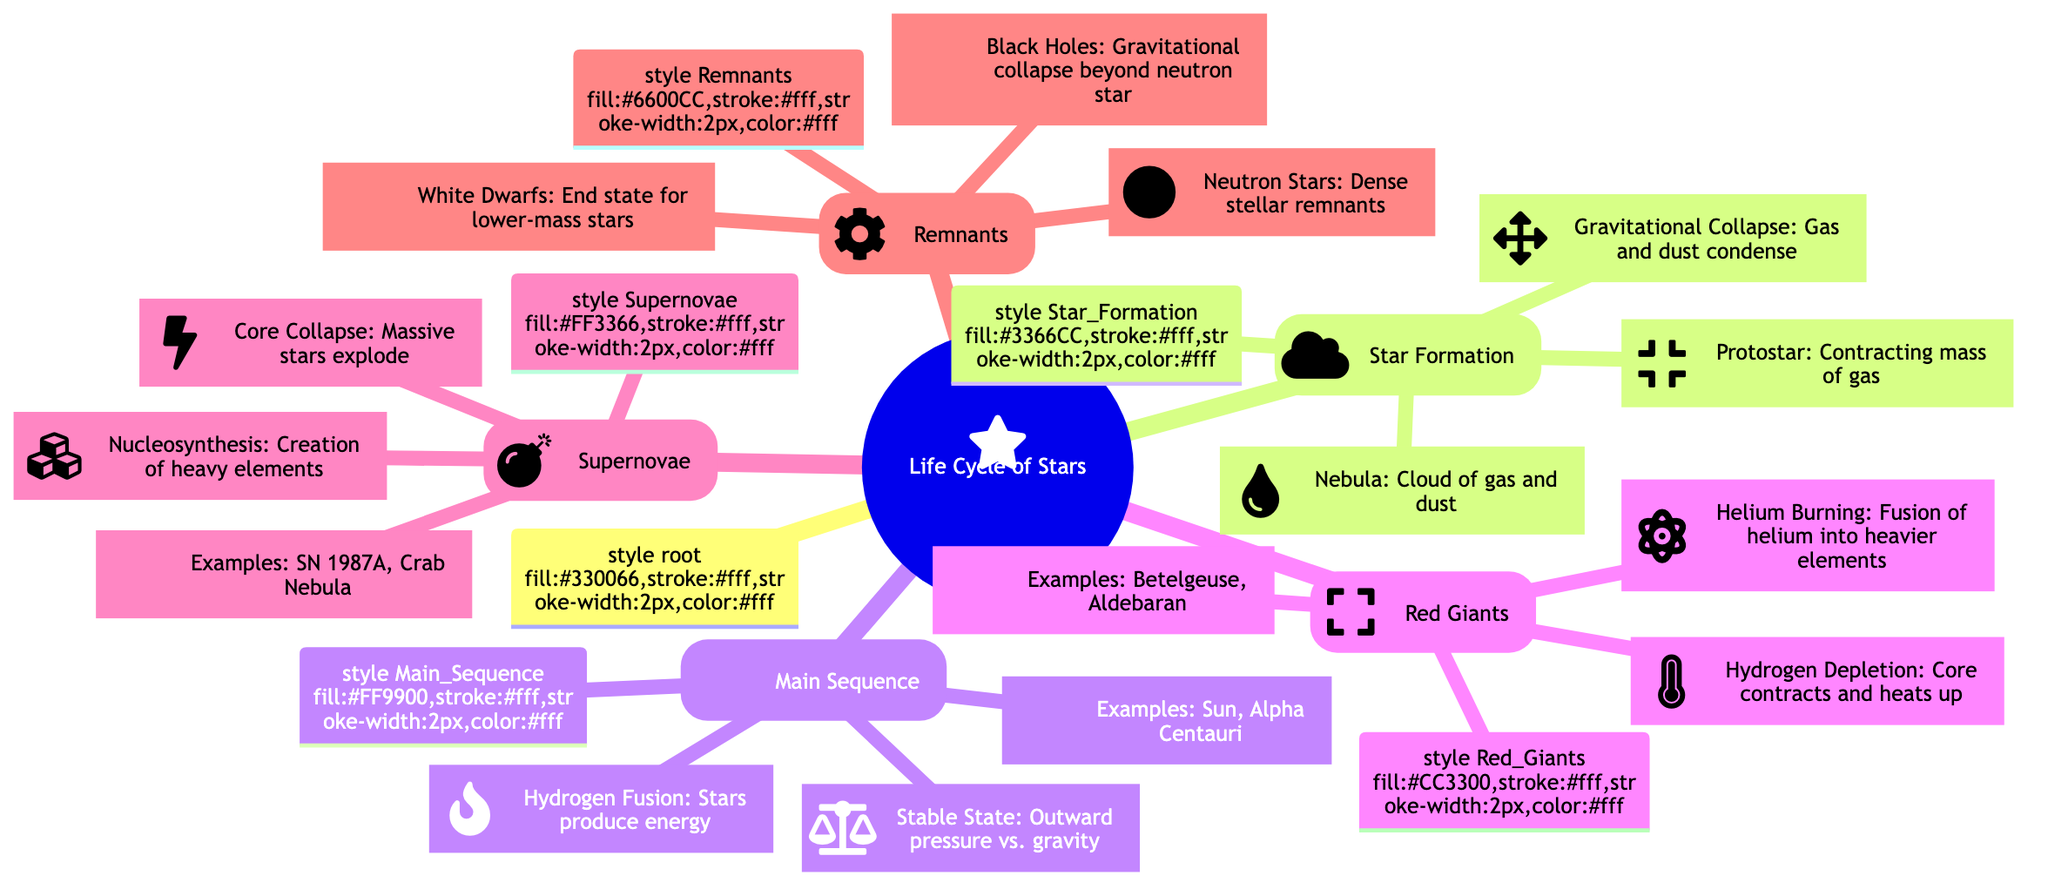What are the three stages of star formation? According to the diagram, the three stages of star formation listed are "Nebula," "Protostar," and "Gravitational Collapse." These are the initial phases that a star goes through before entering the main sequence.
Answer: Nebula, Protostar, Gravitational Collapse How many examples of red giants are mentioned? The diagram states that there are two examples of red giants, specifically "Betelgeuse" and "Aldebaran." Therefore, we count these to determine the total.
Answer: Two What key process occurs during the main sequence stage? The diagram highlights "Hydrogen Fusion" as a significant process during the main sequence of a star's life cycle, which is critical for energy production.
Answer: Hydrogen Fusion What happens during a supernova? According to the diagram, during a supernova, there is a "Core Collapse" where massive stars explode. This dramatic event is part of the life cycle of stars.
Answer: Core Collapse What are the remnants of a star after a supernova? The diagram lists three types of stellar remnants after a supernova: "Neutron Stars," "Black Holes," and "White Dwarfs." These represent the end states that stars may collapse into.
Answer: Neutron Stars, Black Holes, White Dwarfs What is the relationship between hydrogen depletion and red giants? The diagram indicates that "Hydrogen Depletion" leads to "Helium Burning," which is a condition that occurs in red giants as they exhaust their hydrogen supply and start fusing helium.
Answer: Hydrogen Depletion leads to Helium Burning What type of celestial object is formed from core collapse? The diagram illustrates that from core collapse, one possible outcome is a "Neutron Star," which reflects the different types of remnants formed post-supernova.
Answer: Neutron Star What does nucleosynthesis create? The diagram connects "Nucleosynthesis" to the creation of "heavy elements" during supernova events, indicating the role supernovae play in enriching the universe with heavier elements.
Answer: Heavy elements Which star type is our Sun classified as? In the main sequence section, the diagram indicates that the "Sun" is an example of a star within that stage, which helps classify its type within the stellar evolution framework.
Answer: Main Sequence 